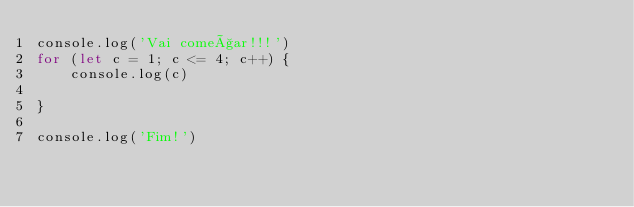<code> <loc_0><loc_0><loc_500><loc_500><_JavaScript_>console.log('Vai começar!!!')
for (let c = 1; c <= 4; c++) {
    console.log(c)
    
}

console.log('Fim!')</code> 